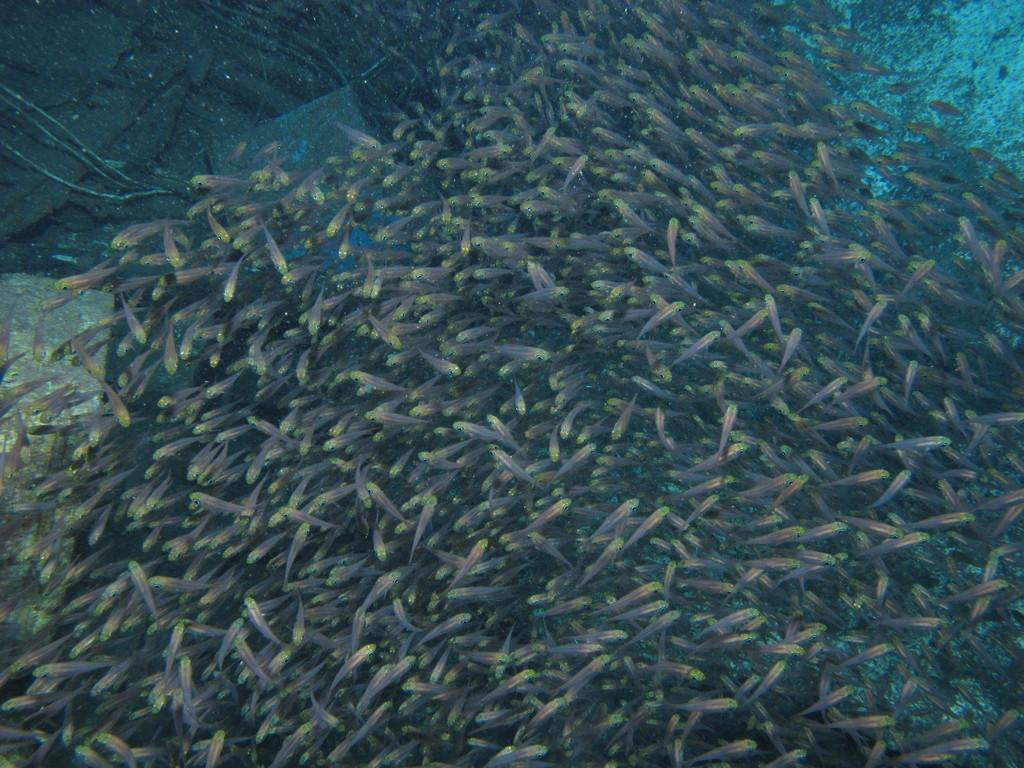What body of water is present in the image? There is a pond in the image. What can be found in the pond? There is a group of fishes in the pond. What is the name of the insect that is flying over the pond in the image? There is no insect present in the image, so it is not possible to determine its name. 